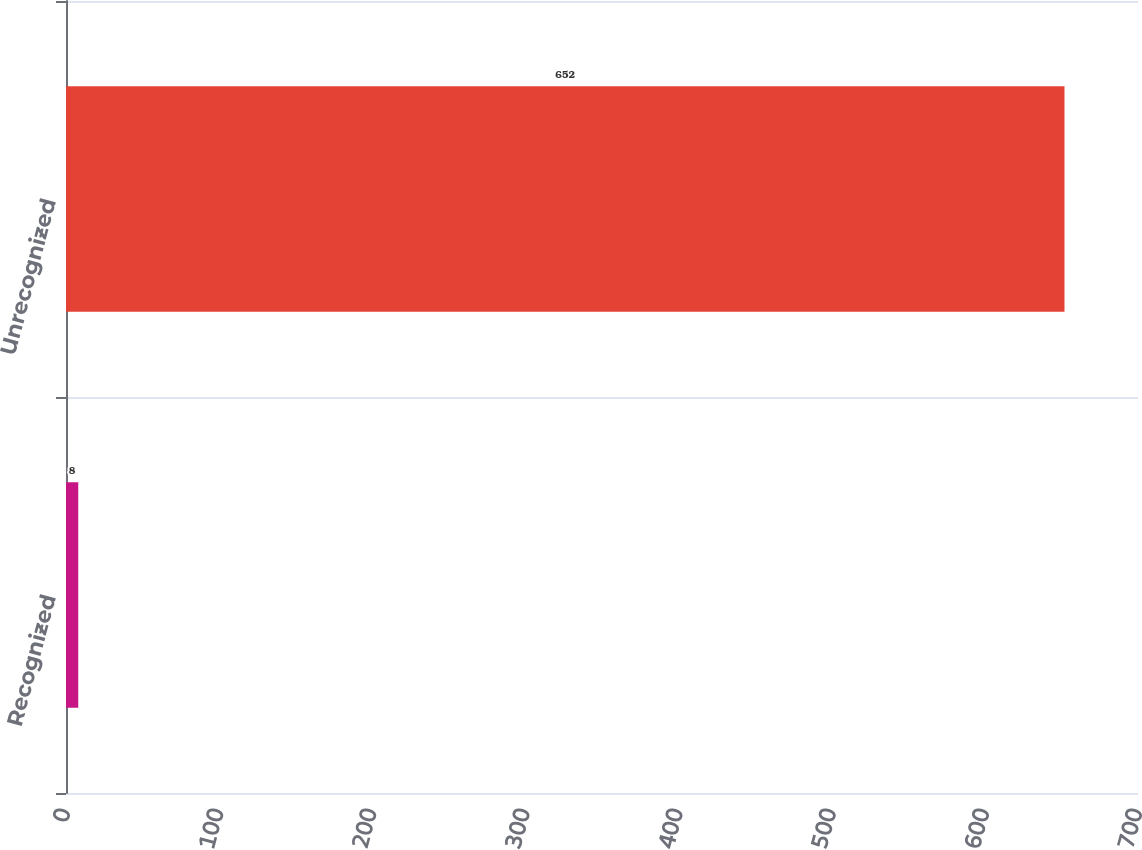Convert chart. <chart><loc_0><loc_0><loc_500><loc_500><bar_chart><fcel>Recognized<fcel>Unrecognized<nl><fcel>8<fcel>652<nl></chart> 